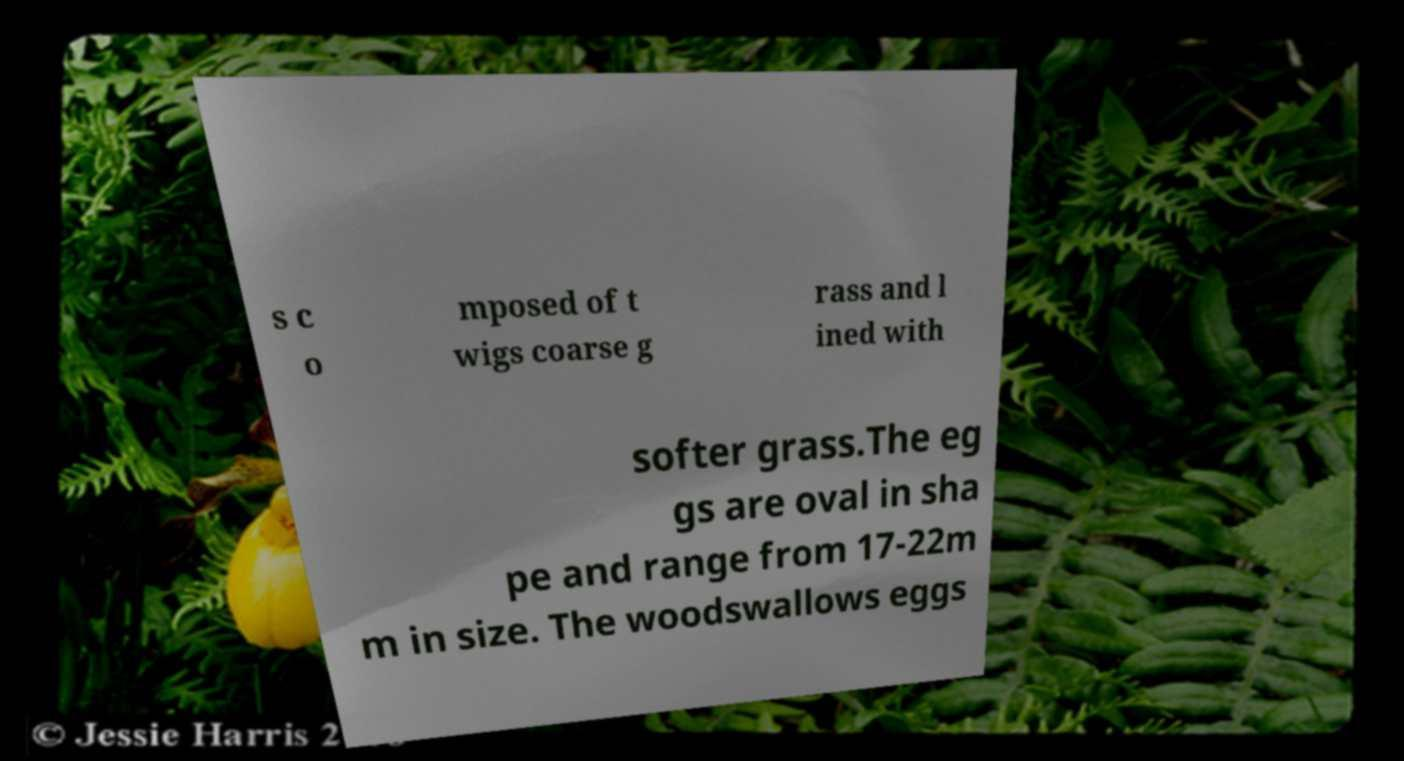Could you assist in decoding the text presented in this image and type it out clearly? s c o mposed of t wigs coarse g rass and l ined with softer grass.The eg gs are oval in sha pe and range from 17-22m m in size. The woodswallows eggs 